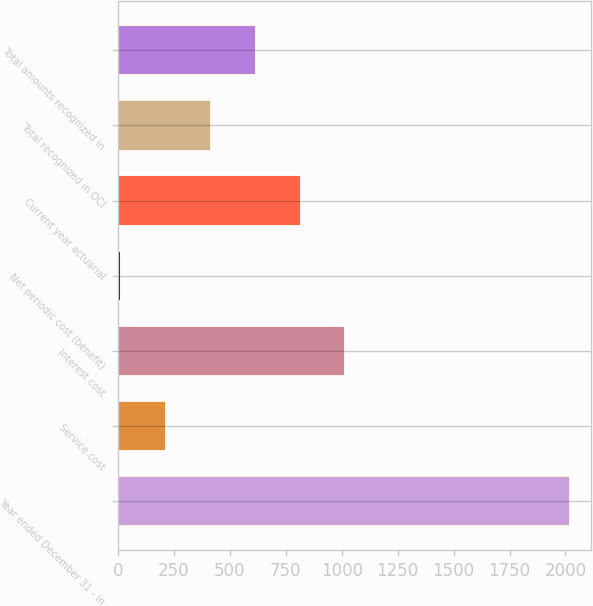Convert chart. <chart><loc_0><loc_0><loc_500><loc_500><bar_chart><fcel>Year ended December 31 - in<fcel>Service cost<fcel>Interest cost<fcel>Net periodic cost (benefit)<fcel>Current year actuarial<fcel>Total recognized in OCI<fcel>Total amounts recognized in<nl><fcel>2015<fcel>209.6<fcel>1012<fcel>9<fcel>811.4<fcel>410.2<fcel>610.8<nl></chart> 